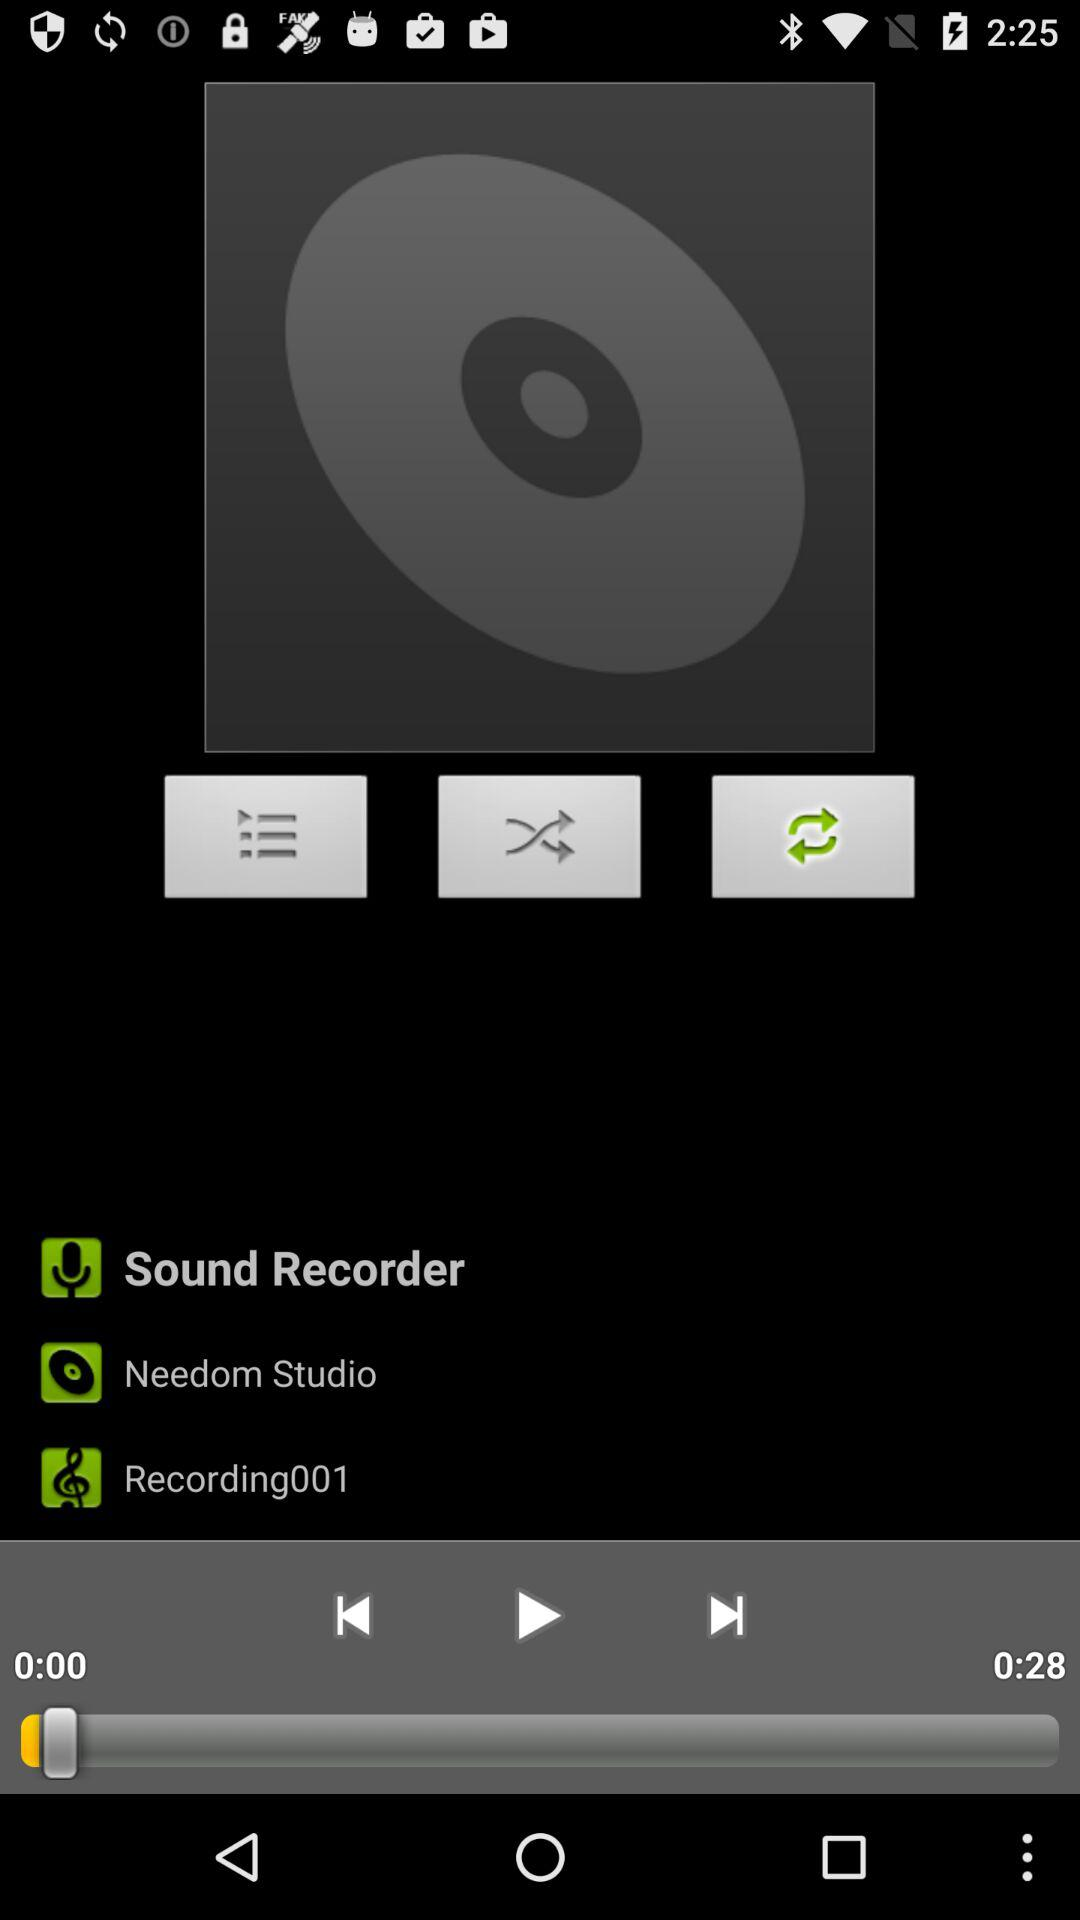What is the duration of the audio? The duration is 28 seconds. 